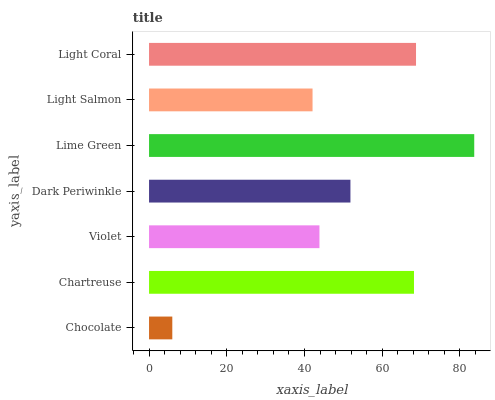Is Chocolate the minimum?
Answer yes or no. Yes. Is Lime Green the maximum?
Answer yes or no. Yes. Is Chartreuse the minimum?
Answer yes or no. No. Is Chartreuse the maximum?
Answer yes or no. No. Is Chartreuse greater than Chocolate?
Answer yes or no. Yes. Is Chocolate less than Chartreuse?
Answer yes or no. Yes. Is Chocolate greater than Chartreuse?
Answer yes or no. No. Is Chartreuse less than Chocolate?
Answer yes or no. No. Is Dark Periwinkle the high median?
Answer yes or no. Yes. Is Dark Periwinkle the low median?
Answer yes or no. Yes. Is Lime Green the high median?
Answer yes or no. No. Is Violet the low median?
Answer yes or no. No. 